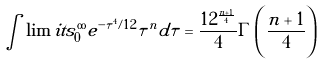Convert formula to latex. <formula><loc_0><loc_0><loc_500><loc_500>\int \lim i t s _ { 0 } ^ { \infty } e ^ { - \tau ^ { 4 } / 1 2 } \tau ^ { n } d \tau = \frac { 1 2 ^ { \frac { n + 1 } 4 } } { 4 } \Gamma \left ( \frac { n + 1 } 4 \right )</formula> 